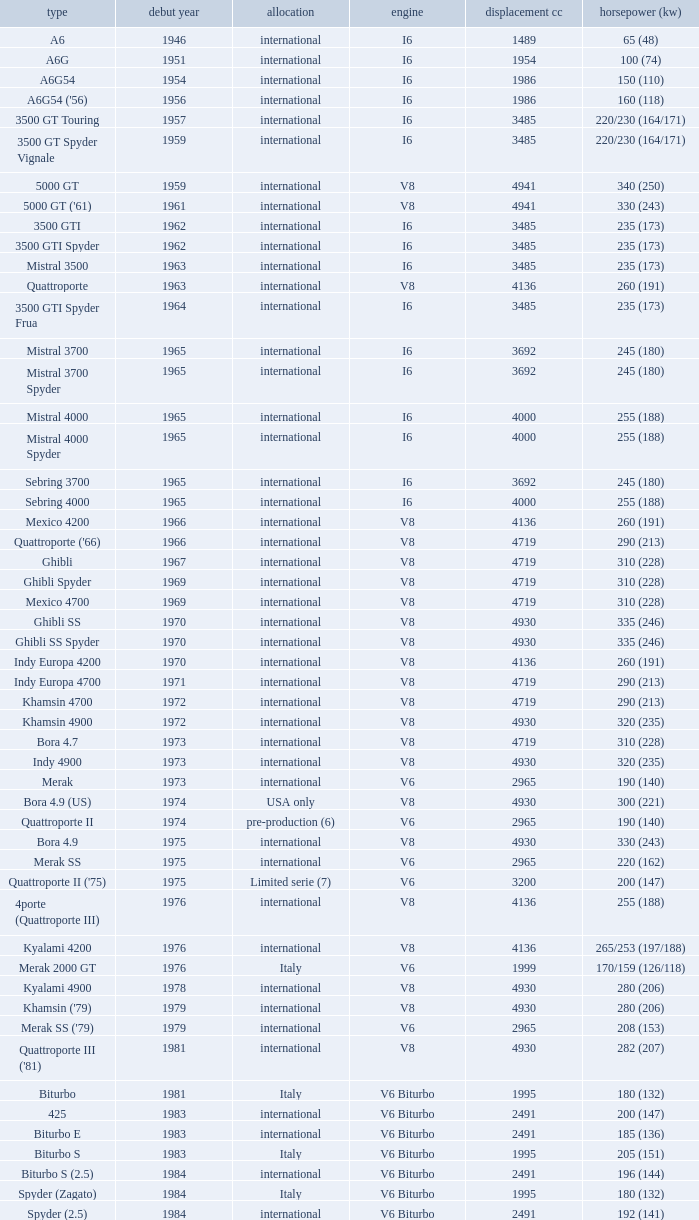What is Power HP (kW), when First Year is greater than 1965, when Distribution is "International", when Engine is V6 Biturbo, and when Model is "425"? 200 (147). 